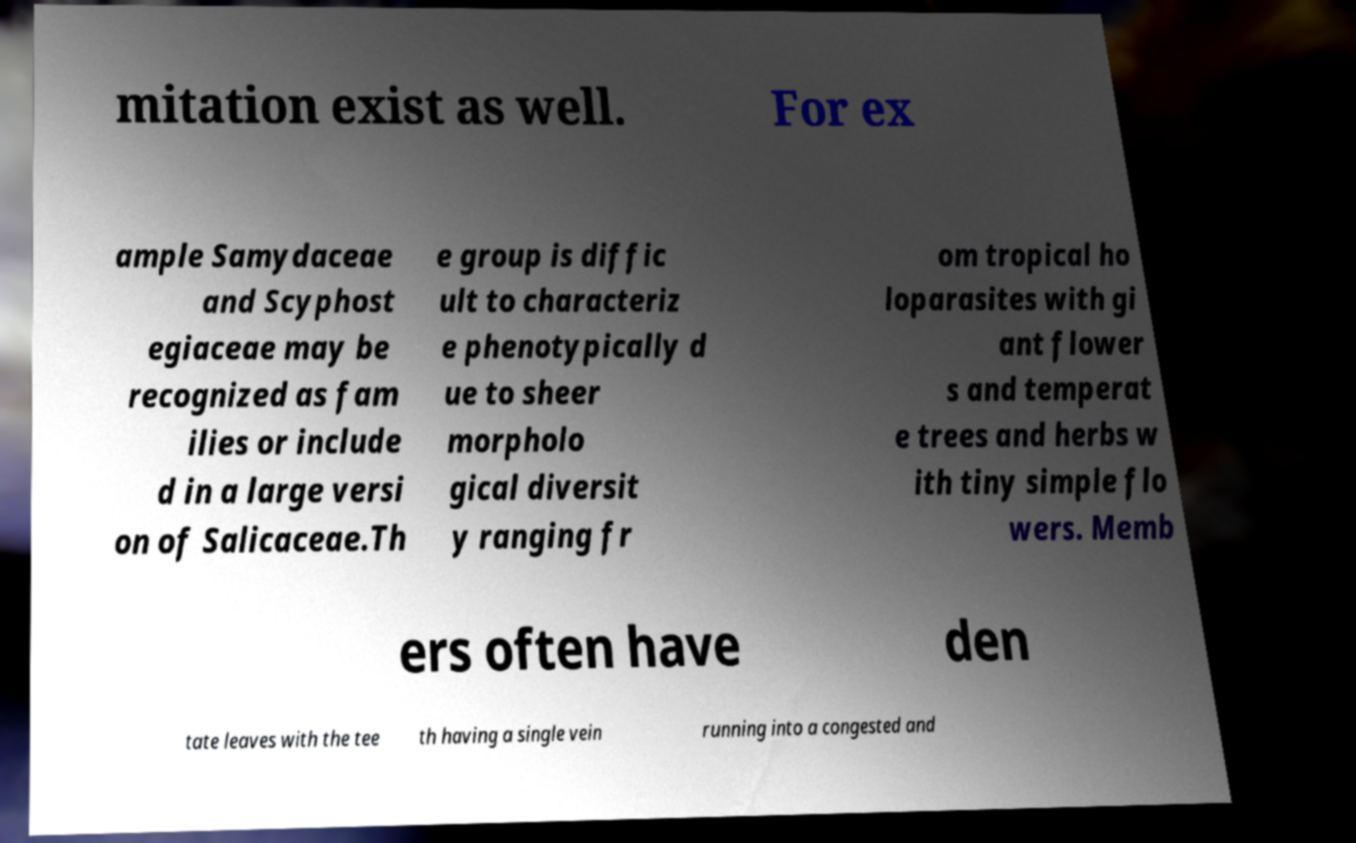Can you read and provide the text displayed in the image?This photo seems to have some interesting text. Can you extract and type it out for me? mitation exist as well. For ex ample Samydaceae and Scyphost egiaceae may be recognized as fam ilies or include d in a large versi on of Salicaceae.Th e group is diffic ult to characteriz e phenotypically d ue to sheer morpholo gical diversit y ranging fr om tropical ho loparasites with gi ant flower s and temperat e trees and herbs w ith tiny simple flo wers. Memb ers often have den tate leaves with the tee th having a single vein running into a congested and 